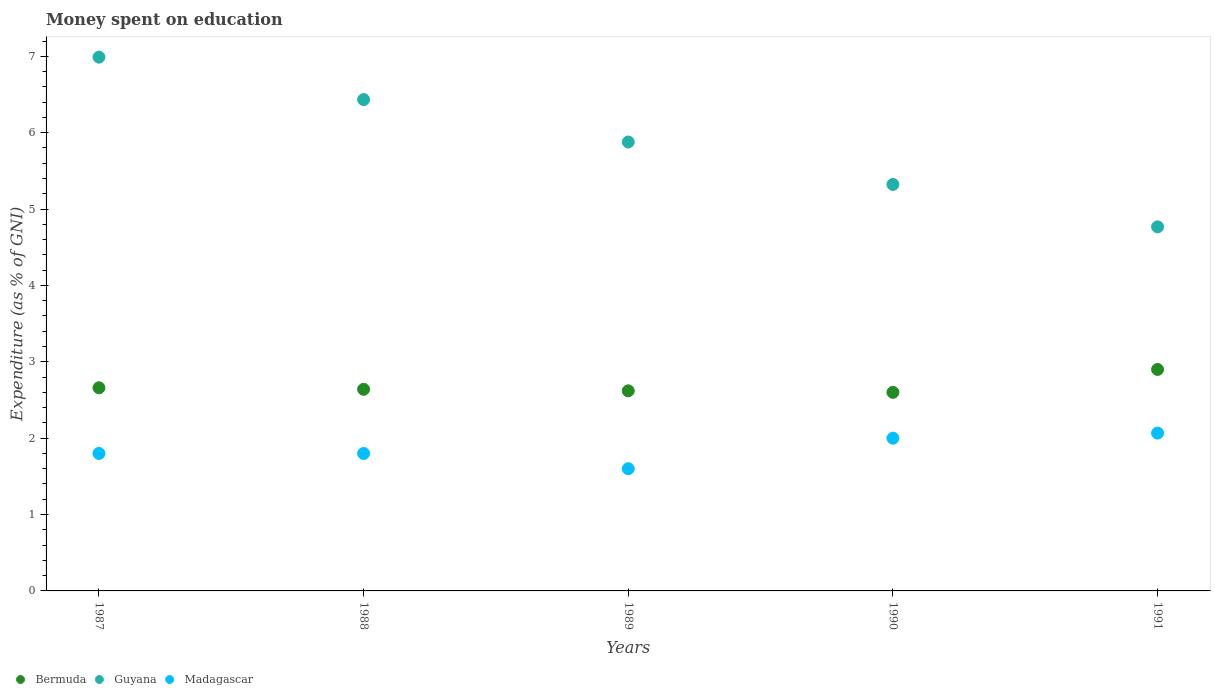Across all years, what is the maximum amount of money spent on education in Madagascar?
Provide a succinct answer. 2.07. What is the total amount of money spent on education in Madagascar in the graph?
Offer a very short reply. 9.27. What is the difference between the amount of money spent on education in Madagascar in 1989 and that in 1990?
Provide a short and direct response. -0.4. What is the difference between the amount of money spent on education in Madagascar in 1988 and the amount of money spent on education in Bermuda in 1989?
Provide a succinct answer. -0.82. What is the average amount of money spent on education in Madagascar per year?
Provide a succinct answer. 1.85. In the year 1987, what is the difference between the amount of money spent on education in Madagascar and amount of money spent on education in Bermuda?
Keep it short and to the point. -0.86. What is the ratio of the amount of money spent on education in Guyana in 1987 to that in 1989?
Your answer should be compact. 1.19. Is the amount of money spent on education in Guyana in 1987 less than that in 1988?
Ensure brevity in your answer.  No. Is the difference between the amount of money spent on education in Madagascar in 1988 and 1991 greater than the difference between the amount of money spent on education in Bermuda in 1988 and 1991?
Offer a terse response. No. What is the difference between the highest and the second highest amount of money spent on education in Bermuda?
Keep it short and to the point. 0.24. What is the difference between the highest and the lowest amount of money spent on education in Bermuda?
Your response must be concise. 0.3. Is it the case that in every year, the sum of the amount of money spent on education in Bermuda and amount of money spent on education in Madagascar  is greater than the amount of money spent on education in Guyana?
Give a very brief answer. No. Does the amount of money spent on education in Bermuda monotonically increase over the years?
Keep it short and to the point. No. Does the graph contain any zero values?
Make the answer very short. No. How many legend labels are there?
Keep it short and to the point. 3. How are the legend labels stacked?
Offer a terse response. Horizontal. What is the title of the graph?
Your answer should be compact. Money spent on education. Does "South Sudan" appear as one of the legend labels in the graph?
Keep it short and to the point. No. What is the label or title of the X-axis?
Your answer should be very brief. Years. What is the label or title of the Y-axis?
Provide a short and direct response. Expenditure (as % of GNI). What is the Expenditure (as % of GNI) in Bermuda in 1987?
Your response must be concise. 2.66. What is the Expenditure (as % of GNI) of Guyana in 1987?
Provide a succinct answer. 6.99. What is the Expenditure (as % of GNI) in Madagascar in 1987?
Provide a succinct answer. 1.8. What is the Expenditure (as % of GNI) in Bermuda in 1988?
Provide a succinct answer. 2.64. What is the Expenditure (as % of GNI) in Guyana in 1988?
Your response must be concise. 6.43. What is the Expenditure (as % of GNI) in Bermuda in 1989?
Offer a very short reply. 2.62. What is the Expenditure (as % of GNI) of Guyana in 1989?
Your answer should be very brief. 5.88. What is the Expenditure (as % of GNI) of Madagascar in 1989?
Ensure brevity in your answer.  1.6. What is the Expenditure (as % of GNI) in Guyana in 1990?
Your answer should be very brief. 5.32. What is the Expenditure (as % of GNI) in Madagascar in 1990?
Keep it short and to the point. 2. What is the Expenditure (as % of GNI) in Bermuda in 1991?
Keep it short and to the point. 2.9. What is the Expenditure (as % of GNI) of Guyana in 1991?
Offer a terse response. 4.77. What is the Expenditure (as % of GNI) in Madagascar in 1991?
Provide a succinct answer. 2.07. Across all years, what is the maximum Expenditure (as % of GNI) in Guyana?
Provide a short and direct response. 6.99. Across all years, what is the maximum Expenditure (as % of GNI) of Madagascar?
Provide a succinct answer. 2.07. Across all years, what is the minimum Expenditure (as % of GNI) of Guyana?
Your response must be concise. 4.77. What is the total Expenditure (as % of GNI) in Bermuda in the graph?
Offer a very short reply. 13.42. What is the total Expenditure (as % of GNI) of Guyana in the graph?
Your answer should be compact. 29.39. What is the total Expenditure (as % of GNI) of Madagascar in the graph?
Offer a terse response. 9.27. What is the difference between the Expenditure (as % of GNI) of Bermuda in 1987 and that in 1988?
Your answer should be very brief. 0.02. What is the difference between the Expenditure (as % of GNI) in Guyana in 1987 and that in 1988?
Provide a short and direct response. 0.56. What is the difference between the Expenditure (as % of GNI) of Bermuda in 1987 and that in 1989?
Provide a short and direct response. 0.04. What is the difference between the Expenditure (as % of GNI) of Guyana in 1987 and that in 1989?
Offer a very short reply. 1.11. What is the difference between the Expenditure (as % of GNI) of Madagascar in 1987 and that in 1989?
Your answer should be compact. 0.2. What is the difference between the Expenditure (as % of GNI) in Guyana in 1987 and that in 1990?
Your answer should be very brief. 1.67. What is the difference between the Expenditure (as % of GNI) in Madagascar in 1987 and that in 1990?
Provide a succinct answer. -0.2. What is the difference between the Expenditure (as % of GNI) in Bermuda in 1987 and that in 1991?
Keep it short and to the point. -0.24. What is the difference between the Expenditure (as % of GNI) of Guyana in 1987 and that in 1991?
Ensure brevity in your answer.  2.22. What is the difference between the Expenditure (as % of GNI) of Madagascar in 1987 and that in 1991?
Offer a terse response. -0.27. What is the difference between the Expenditure (as % of GNI) in Guyana in 1988 and that in 1989?
Your answer should be very brief. 0.56. What is the difference between the Expenditure (as % of GNI) of Guyana in 1988 and that in 1990?
Your answer should be compact. 1.11. What is the difference between the Expenditure (as % of GNI) of Bermuda in 1988 and that in 1991?
Keep it short and to the point. -0.26. What is the difference between the Expenditure (as % of GNI) in Guyana in 1988 and that in 1991?
Make the answer very short. 1.67. What is the difference between the Expenditure (as % of GNI) of Madagascar in 1988 and that in 1991?
Your answer should be compact. -0.27. What is the difference between the Expenditure (as % of GNI) in Bermuda in 1989 and that in 1990?
Your answer should be compact. 0.02. What is the difference between the Expenditure (as % of GNI) in Guyana in 1989 and that in 1990?
Make the answer very short. 0.56. What is the difference between the Expenditure (as % of GNI) in Bermuda in 1989 and that in 1991?
Your answer should be compact. -0.28. What is the difference between the Expenditure (as % of GNI) in Guyana in 1989 and that in 1991?
Your response must be concise. 1.11. What is the difference between the Expenditure (as % of GNI) in Madagascar in 1989 and that in 1991?
Provide a short and direct response. -0.47. What is the difference between the Expenditure (as % of GNI) in Bermuda in 1990 and that in 1991?
Provide a succinct answer. -0.3. What is the difference between the Expenditure (as % of GNI) of Guyana in 1990 and that in 1991?
Your answer should be compact. 0.56. What is the difference between the Expenditure (as % of GNI) in Madagascar in 1990 and that in 1991?
Offer a terse response. -0.07. What is the difference between the Expenditure (as % of GNI) of Bermuda in 1987 and the Expenditure (as % of GNI) of Guyana in 1988?
Provide a succinct answer. -3.77. What is the difference between the Expenditure (as % of GNI) in Bermuda in 1987 and the Expenditure (as % of GNI) in Madagascar in 1988?
Your answer should be compact. 0.86. What is the difference between the Expenditure (as % of GNI) in Guyana in 1987 and the Expenditure (as % of GNI) in Madagascar in 1988?
Provide a short and direct response. 5.19. What is the difference between the Expenditure (as % of GNI) of Bermuda in 1987 and the Expenditure (as % of GNI) of Guyana in 1989?
Make the answer very short. -3.22. What is the difference between the Expenditure (as % of GNI) in Bermuda in 1987 and the Expenditure (as % of GNI) in Madagascar in 1989?
Make the answer very short. 1.06. What is the difference between the Expenditure (as % of GNI) in Guyana in 1987 and the Expenditure (as % of GNI) in Madagascar in 1989?
Give a very brief answer. 5.39. What is the difference between the Expenditure (as % of GNI) of Bermuda in 1987 and the Expenditure (as % of GNI) of Guyana in 1990?
Your response must be concise. -2.66. What is the difference between the Expenditure (as % of GNI) of Bermuda in 1987 and the Expenditure (as % of GNI) of Madagascar in 1990?
Give a very brief answer. 0.66. What is the difference between the Expenditure (as % of GNI) of Guyana in 1987 and the Expenditure (as % of GNI) of Madagascar in 1990?
Your answer should be very brief. 4.99. What is the difference between the Expenditure (as % of GNI) of Bermuda in 1987 and the Expenditure (as % of GNI) of Guyana in 1991?
Your response must be concise. -2.11. What is the difference between the Expenditure (as % of GNI) of Bermuda in 1987 and the Expenditure (as % of GNI) of Madagascar in 1991?
Make the answer very short. 0.59. What is the difference between the Expenditure (as % of GNI) of Guyana in 1987 and the Expenditure (as % of GNI) of Madagascar in 1991?
Ensure brevity in your answer.  4.92. What is the difference between the Expenditure (as % of GNI) of Bermuda in 1988 and the Expenditure (as % of GNI) of Guyana in 1989?
Provide a short and direct response. -3.24. What is the difference between the Expenditure (as % of GNI) of Guyana in 1988 and the Expenditure (as % of GNI) of Madagascar in 1989?
Offer a terse response. 4.83. What is the difference between the Expenditure (as % of GNI) of Bermuda in 1988 and the Expenditure (as % of GNI) of Guyana in 1990?
Keep it short and to the point. -2.68. What is the difference between the Expenditure (as % of GNI) of Bermuda in 1988 and the Expenditure (as % of GNI) of Madagascar in 1990?
Give a very brief answer. 0.64. What is the difference between the Expenditure (as % of GNI) in Guyana in 1988 and the Expenditure (as % of GNI) in Madagascar in 1990?
Your answer should be very brief. 4.43. What is the difference between the Expenditure (as % of GNI) of Bermuda in 1988 and the Expenditure (as % of GNI) of Guyana in 1991?
Offer a very short reply. -2.13. What is the difference between the Expenditure (as % of GNI) of Bermuda in 1988 and the Expenditure (as % of GNI) of Madagascar in 1991?
Your response must be concise. 0.57. What is the difference between the Expenditure (as % of GNI) in Guyana in 1988 and the Expenditure (as % of GNI) in Madagascar in 1991?
Your answer should be very brief. 4.37. What is the difference between the Expenditure (as % of GNI) of Bermuda in 1989 and the Expenditure (as % of GNI) of Guyana in 1990?
Ensure brevity in your answer.  -2.7. What is the difference between the Expenditure (as % of GNI) in Bermuda in 1989 and the Expenditure (as % of GNI) in Madagascar in 1990?
Offer a terse response. 0.62. What is the difference between the Expenditure (as % of GNI) in Guyana in 1989 and the Expenditure (as % of GNI) in Madagascar in 1990?
Keep it short and to the point. 3.88. What is the difference between the Expenditure (as % of GNI) of Bermuda in 1989 and the Expenditure (as % of GNI) of Guyana in 1991?
Your response must be concise. -2.15. What is the difference between the Expenditure (as % of GNI) of Bermuda in 1989 and the Expenditure (as % of GNI) of Madagascar in 1991?
Provide a short and direct response. 0.55. What is the difference between the Expenditure (as % of GNI) of Guyana in 1989 and the Expenditure (as % of GNI) of Madagascar in 1991?
Offer a terse response. 3.81. What is the difference between the Expenditure (as % of GNI) of Bermuda in 1990 and the Expenditure (as % of GNI) of Guyana in 1991?
Offer a terse response. -2.17. What is the difference between the Expenditure (as % of GNI) of Bermuda in 1990 and the Expenditure (as % of GNI) of Madagascar in 1991?
Ensure brevity in your answer.  0.53. What is the difference between the Expenditure (as % of GNI) in Guyana in 1990 and the Expenditure (as % of GNI) in Madagascar in 1991?
Your answer should be compact. 3.26. What is the average Expenditure (as % of GNI) of Bermuda per year?
Give a very brief answer. 2.68. What is the average Expenditure (as % of GNI) in Guyana per year?
Your response must be concise. 5.88. What is the average Expenditure (as % of GNI) of Madagascar per year?
Offer a very short reply. 1.85. In the year 1987, what is the difference between the Expenditure (as % of GNI) of Bermuda and Expenditure (as % of GNI) of Guyana?
Your answer should be very brief. -4.33. In the year 1987, what is the difference between the Expenditure (as % of GNI) of Bermuda and Expenditure (as % of GNI) of Madagascar?
Provide a succinct answer. 0.86. In the year 1987, what is the difference between the Expenditure (as % of GNI) in Guyana and Expenditure (as % of GNI) in Madagascar?
Your answer should be compact. 5.19. In the year 1988, what is the difference between the Expenditure (as % of GNI) in Bermuda and Expenditure (as % of GNI) in Guyana?
Provide a succinct answer. -3.79. In the year 1988, what is the difference between the Expenditure (as % of GNI) of Bermuda and Expenditure (as % of GNI) of Madagascar?
Your answer should be very brief. 0.84. In the year 1988, what is the difference between the Expenditure (as % of GNI) of Guyana and Expenditure (as % of GNI) of Madagascar?
Provide a short and direct response. 4.63. In the year 1989, what is the difference between the Expenditure (as % of GNI) of Bermuda and Expenditure (as % of GNI) of Guyana?
Offer a terse response. -3.26. In the year 1989, what is the difference between the Expenditure (as % of GNI) of Bermuda and Expenditure (as % of GNI) of Madagascar?
Offer a terse response. 1.02. In the year 1989, what is the difference between the Expenditure (as % of GNI) in Guyana and Expenditure (as % of GNI) in Madagascar?
Offer a very short reply. 4.28. In the year 1990, what is the difference between the Expenditure (as % of GNI) in Bermuda and Expenditure (as % of GNI) in Guyana?
Provide a succinct answer. -2.72. In the year 1990, what is the difference between the Expenditure (as % of GNI) of Guyana and Expenditure (as % of GNI) of Madagascar?
Your answer should be compact. 3.32. In the year 1991, what is the difference between the Expenditure (as % of GNI) of Bermuda and Expenditure (as % of GNI) of Guyana?
Your response must be concise. -1.87. In the year 1991, what is the difference between the Expenditure (as % of GNI) of Bermuda and Expenditure (as % of GNI) of Madagascar?
Make the answer very short. 0.83. In the year 1991, what is the difference between the Expenditure (as % of GNI) of Guyana and Expenditure (as % of GNI) of Madagascar?
Ensure brevity in your answer.  2.7. What is the ratio of the Expenditure (as % of GNI) in Bermuda in 1987 to that in 1988?
Keep it short and to the point. 1.01. What is the ratio of the Expenditure (as % of GNI) in Guyana in 1987 to that in 1988?
Offer a terse response. 1.09. What is the ratio of the Expenditure (as % of GNI) of Bermuda in 1987 to that in 1989?
Your answer should be compact. 1.02. What is the ratio of the Expenditure (as % of GNI) of Guyana in 1987 to that in 1989?
Make the answer very short. 1.19. What is the ratio of the Expenditure (as % of GNI) of Madagascar in 1987 to that in 1989?
Give a very brief answer. 1.12. What is the ratio of the Expenditure (as % of GNI) of Bermuda in 1987 to that in 1990?
Provide a succinct answer. 1.02. What is the ratio of the Expenditure (as % of GNI) in Guyana in 1987 to that in 1990?
Ensure brevity in your answer.  1.31. What is the ratio of the Expenditure (as % of GNI) in Bermuda in 1987 to that in 1991?
Your answer should be very brief. 0.92. What is the ratio of the Expenditure (as % of GNI) of Guyana in 1987 to that in 1991?
Your answer should be very brief. 1.47. What is the ratio of the Expenditure (as % of GNI) of Madagascar in 1987 to that in 1991?
Your response must be concise. 0.87. What is the ratio of the Expenditure (as % of GNI) of Bermuda in 1988 to that in 1989?
Provide a short and direct response. 1.01. What is the ratio of the Expenditure (as % of GNI) in Guyana in 1988 to that in 1989?
Your answer should be compact. 1.09. What is the ratio of the Expenditure (as % of GNI) of Madagascar in 1988 to that in 1989?
Offer a very short reply. 1.12. What is the ratio of the Expenditure (as % of GNI) of Bermuda in 1988 to that in 1990?
Your answer should be very brief. 1.02. What is the ratio of the Expenditure (as % of GNI) in Guyana in 1988 to that in 1990?
Your answer should be compact. 1.21. What is the ratio of the Expenditure (as % of GNI) of Bermuda in 1988 to that in 1991?
Offer a terse response. 0.91. What is the ratio of the Expenditure (as % of GNI) in Guyana in 1988 to that in 1991?
Provide a succinct answer. 1.35. What is the ratio of the Expenditure (as % of GNI) in Madagascar in 1988 to that in 1991?
Offer a very short reply. 0.87. What is the ratio of the Expenditure (as % of GNI) of Bermuda in 1989 to that in 1990?
Your answer should be very brief. 1.01. What is the ratio of the Expenditure (as % of GNI) of Guyana in 1989 to that in 1990?
Offer a terse response. 1.1. What is the ratio of the Expenditure (as % of GNI) in Madagascar in 1989 to that in 1990?
Offer a terse response. 0.8. What is the ratio of the Expenditure (as % of GNI) in Bermuda in 1989 to that in 1991?
Your response must be concise. 0.9. What is the ratio of the Expenditure (as % of GNI) in Guyana in 1989 to that in 1991?
Provide a short and direct response. 1.23. What is the ratio of the Expenditure (as % of GNI) in Madagascar in 1989 to that in 1991?
Provide a succinct answer. 0.77. What is the ratio of the Expenditure (as % of GNI) of Bermuda in 1990 to that in 1991?
Provide a succinct answer. 0.9. What is the ratio of the Expenditure (as % of GNI) of Guyana in 1990 to that in 1991?
Keep it short and to the point. 1.12. What is the ratio of the Expenditure (as % of GNI) in Madagascar in 1990 to that in 1991?
Your response must be concise. 0.97. What is the difference between the highest and the second highest Expenditure (as % of GNI) of Bermuda?
Offer a very short reply. 0.24. What is the difference between the highest and the second highest Expenditure (as % of GNI) in Guyana?
Offer a very short reply. 0.56. What is the difference between the highest and the second highest Expenditure (as % of GNI) of Madagascar?
Provide a succinct answer. 0.07. What is the difference between the highest and the lowest Expenditure (as % of GNI) in Guyana?
Offer a very short reply. 2.22. What is the difference between the highest and the lowest Expenditure (as % of GNI) of Madagascar?
Provide a succinct answer. 0.47. 